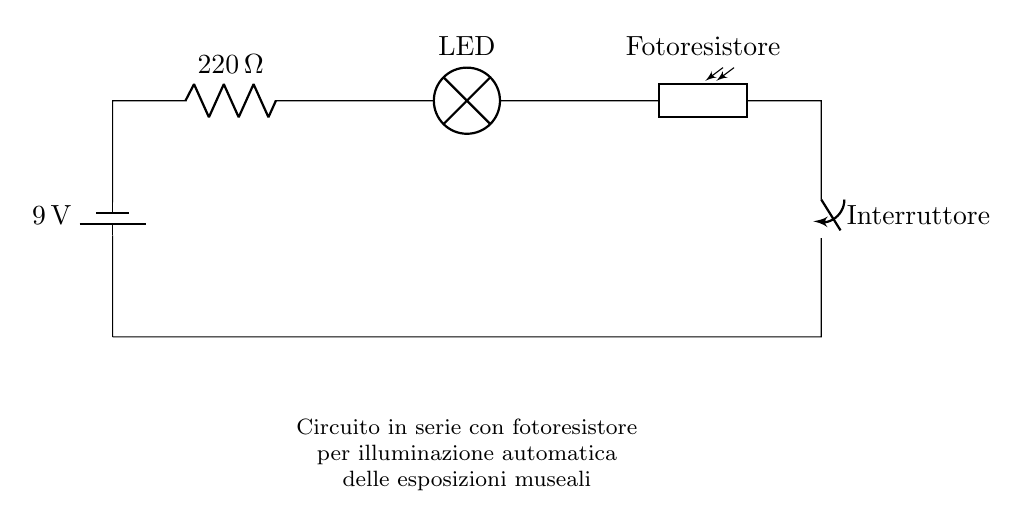What is the voltage of the battery in this circuit? The battery in this circuit provides a voltage of nine volts, which is indicated next to the battery symbol in the diagram.
Answer: nine volts What type of resistor is used in this circuit? The circuit contains a standard resistor with a resistance value of two hundred twenty ohms, which is labeled next to the resistor symbol.
Answer: two hundred twenty ohms What component is used to detect light in this circuit? The component that detects light is called a photoresistor, which is shown in the diagram and labeled "Fotoresistore".
Answer: photoresistor What is the purpose of the switch in this circuit? The switch is used to open or close the circuit, allowing or preventing current from flowing through the other components, thus controlling the lighting.
Answer: control lighting How does the light intensity affect the LED in this circuit? The LED lighting depends on the light intensity detected by the photoresistor; when ambient light levels are low, the resistance of the photoresistor decreases, allowing more current to pass and activating the LED.
Answer: activates the LED What is the overall configuration of the circuit? This circuit is configured as a series circuit, meaning that all components are connected in a single path, and current flows through each component sequentially.
Answer: series circuit What happens when the ambient light increases? When ambient light increases, the resistance of the photoresistor goes up, reducing the current flowing through the circuit and potentially turning off the LED light.
Answer: turns off the LED 